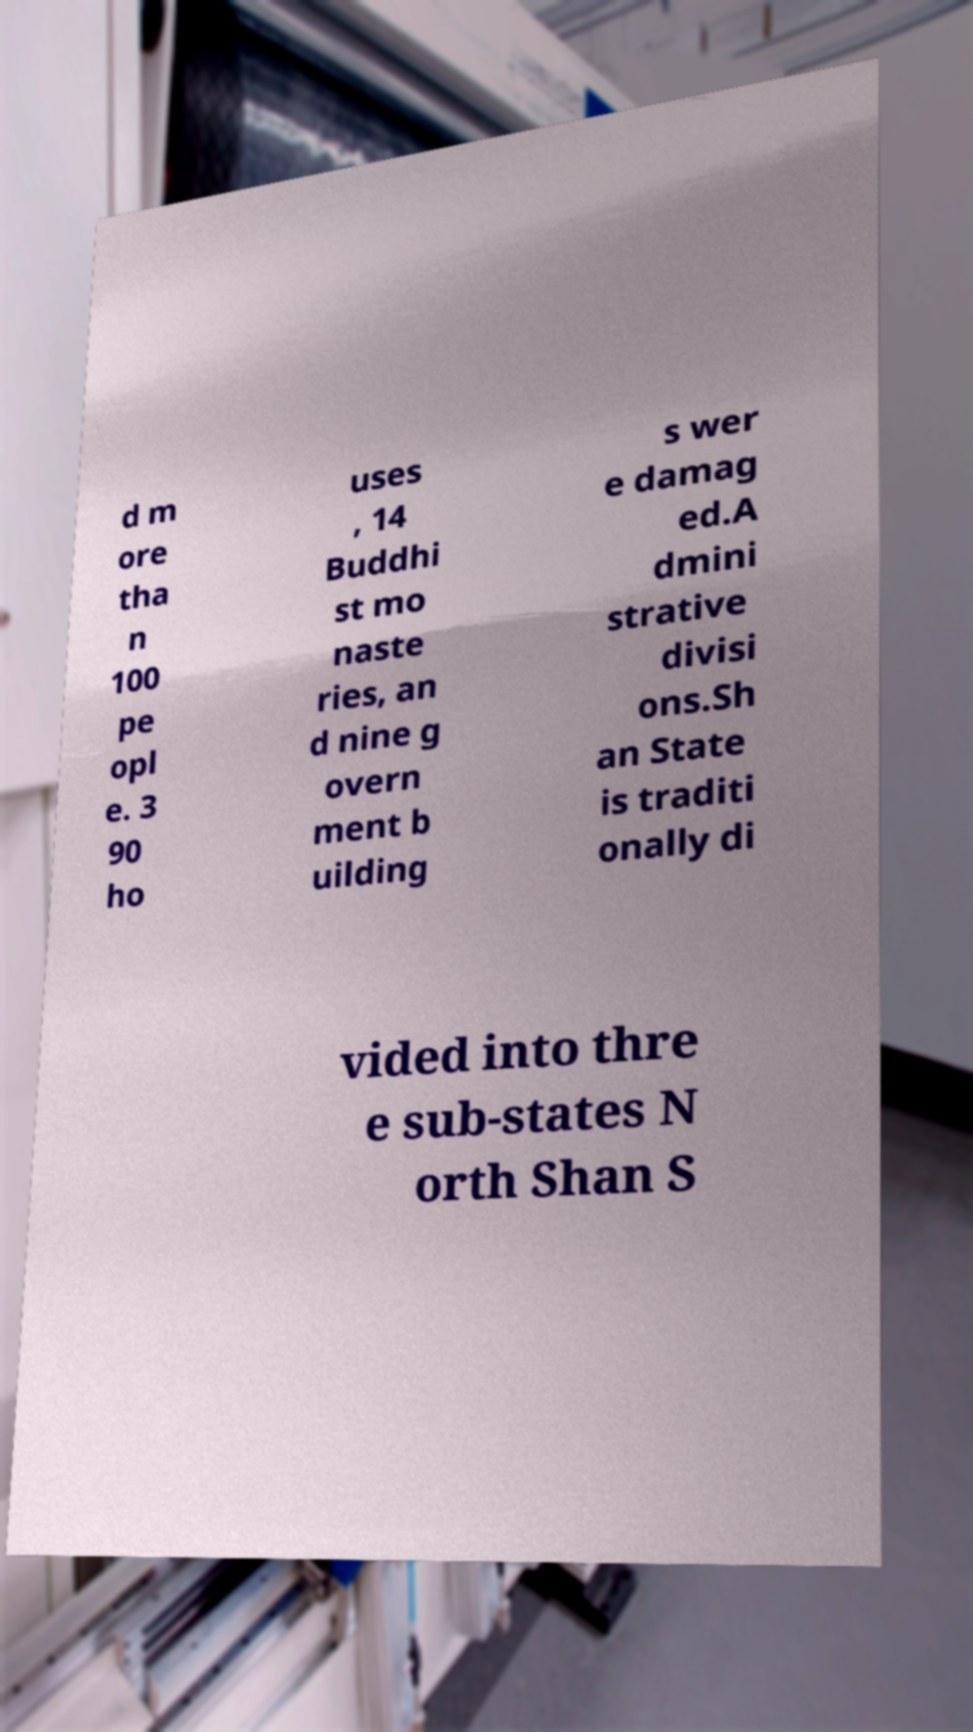Please read and relay the text visible in this image. What does it say? d m ore tha n 100 pe opl e. 3 90 ho uses , 14 Buddhi st mo naste ries, an d nine g overn ment b uilding s wer e damag ed.A dmini strative divisi ons.Sh an State is traditi onally di vided into thre e sub-states N orth Shan S 